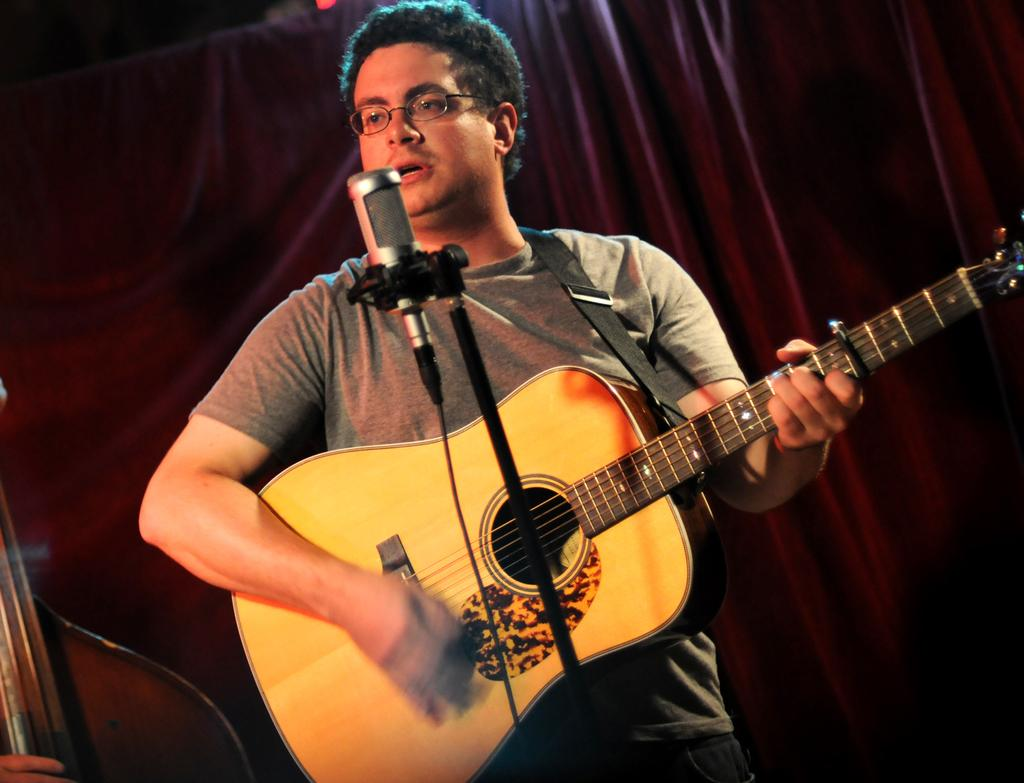Who is the main subject in the image? There is a man in the image. What is the man doing in the image? The man is playing a guitar and singing a song. What object is in front of the man? There is a microphone in front of the man. What type of exchange is taking place between the man and the hall in the image? There is no hall present in the image, and therefore no exchange can be observed between the man and a hall. 